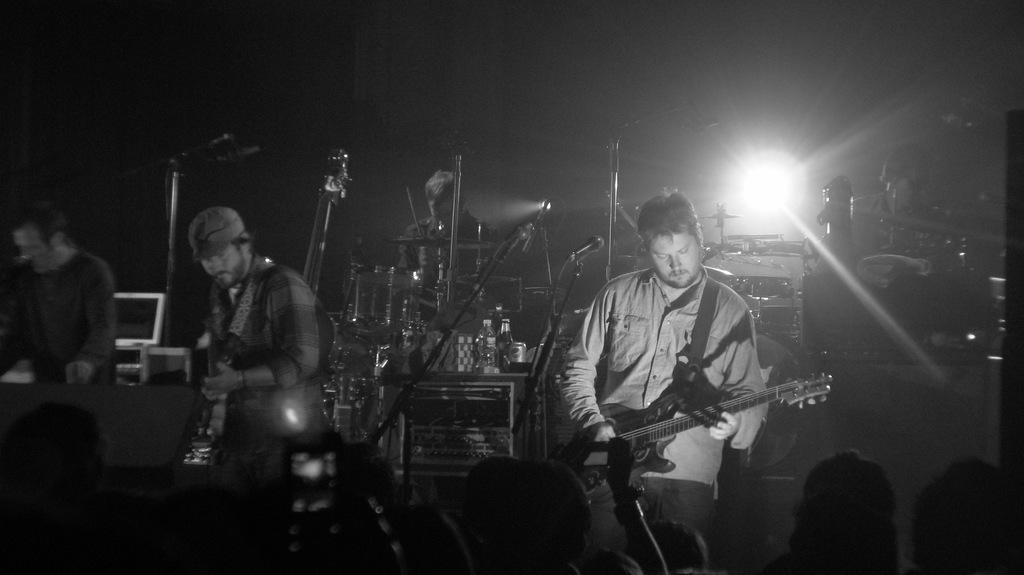What type of event is depicted in the image? The image is from a concert. What instrument is the man in the front playing? The man in the front is playing guitar. What instrument is the man in the background playing? The man in the background is playing drums. Can you describe the audience in the image? There is a crowd at the bottom of the image. How would you describe the lighting in the image? The background is dark. What type of shoe is the guitarist wearing in the image? There is no information about the guitarist's shoes in the image. Can you tell me how many heads of lettuce are visible in the image? There are no heads of lettuce present in the image. 